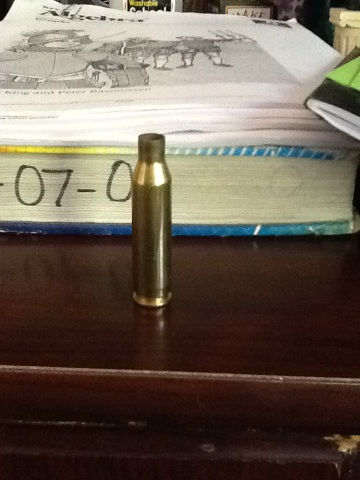What is this? from Vizwiz The object in the image is a brass bullet casing, commonly used in firearms ammunition. It is cylindrical, metallic, and designed to hold the bullet, gunpowder, and primer necessary for firing a gun. 